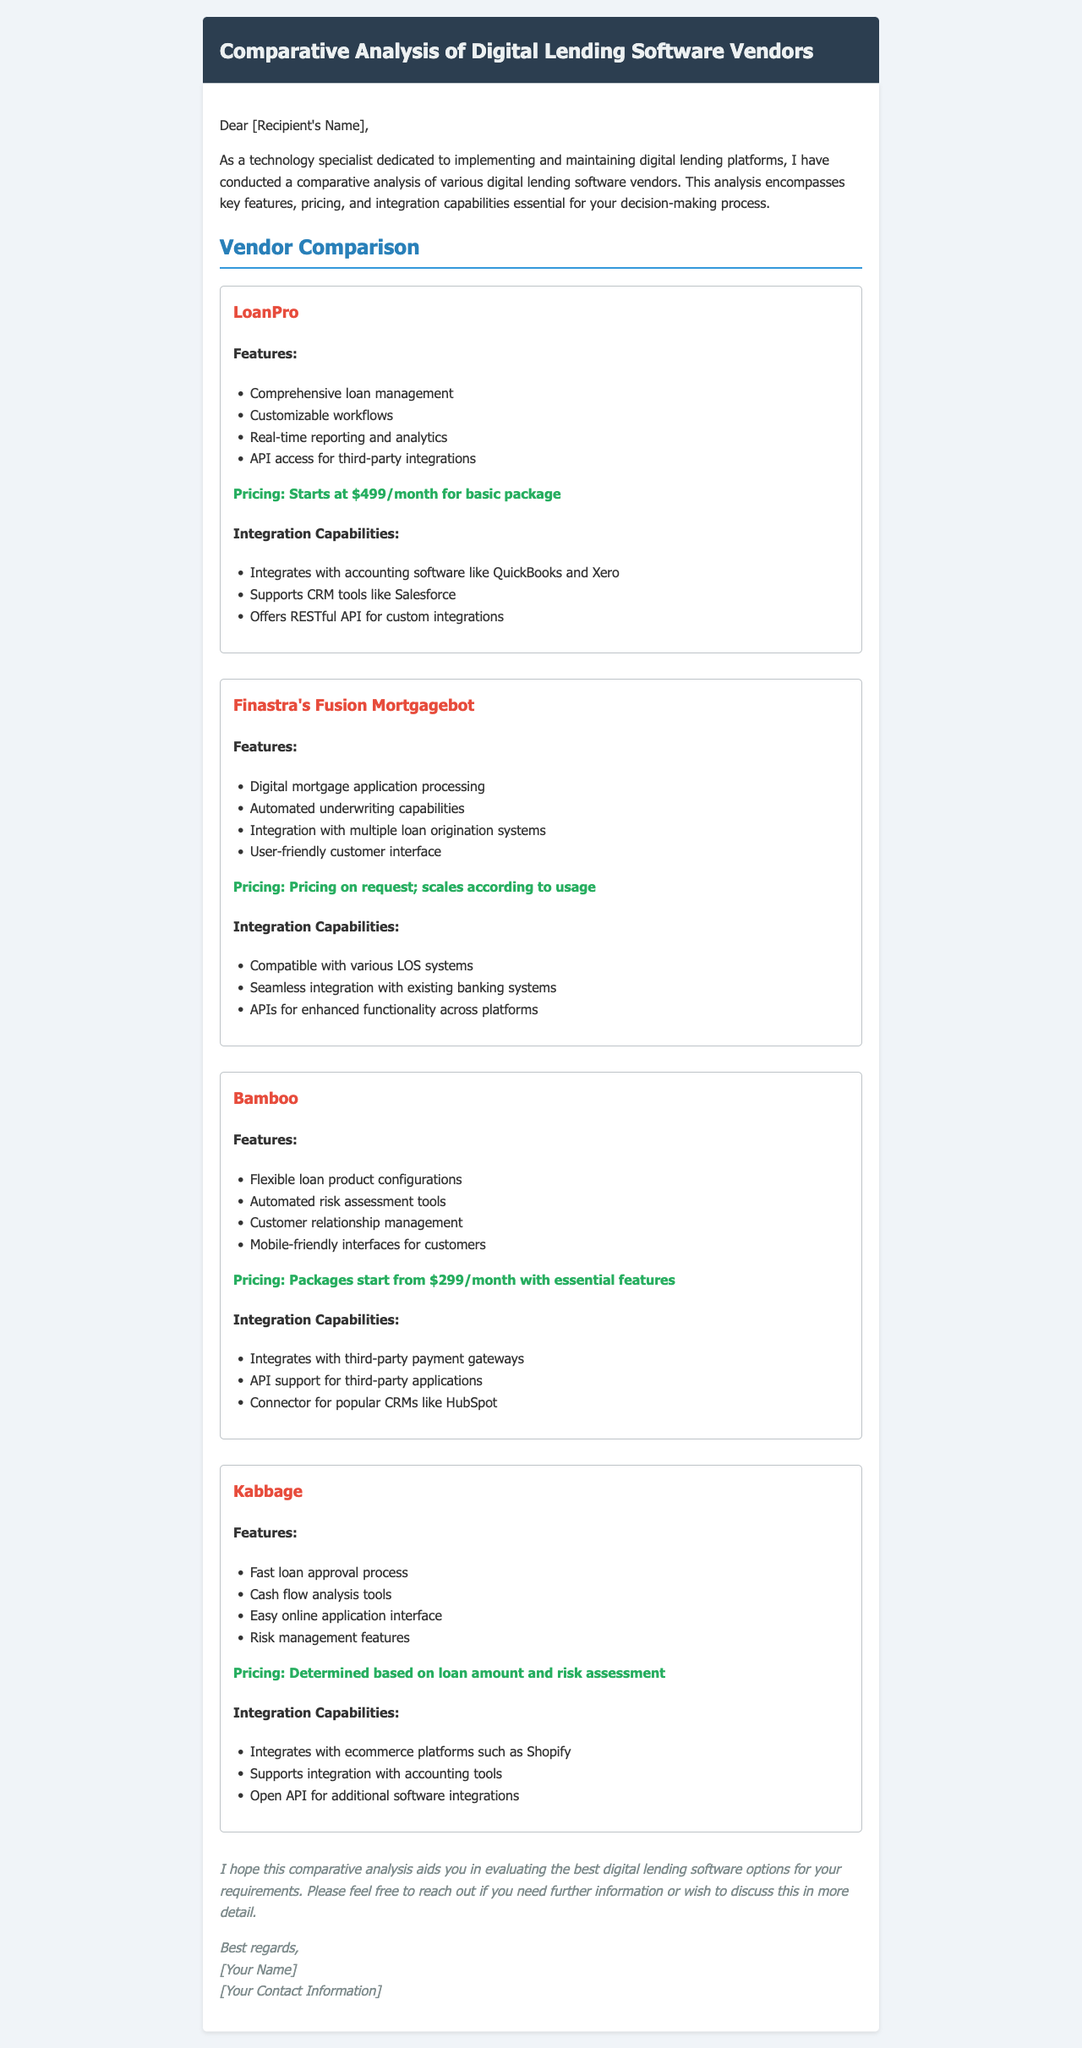What is the starting price for LoanPro's basic package? The starting price for LoanPro's basic package is specifically mentioned in the document.
Answer: $499/month Which vendor offers automated underwriting capabilities? Automated underwriting capabilities are highlighted as a feature of a specific vendor.
Answer: Finastra's Fusion Mortgagebot What feature is common among all vendors? The analysis highlights different features for each vendor, asking for a common feature requires evaluation across the vendors.
Answer: Integration capabilities What is Bamboo's starting package price? The document clearly states the starting package price for Bamboo's features.
Answer: $299/month Which vendor integrates with Shopify? The document indicates which vendor supports integration with the specified e-commerce platform.
Answer: Kabbage How many features does Finastra's Fusion Mortgagebot have listed? The number of features for each vendor is explicitly mentioned, demonstrating the diversity of offerings.
Answer: Four Is API access for third-party integrations a feature of LoanPro? The presence of API access as a feature is directly noted in the vendor's section.
Answer: Yes What type of analysis does Kabbage provide? Kabbage's section specifies the type of analysis related to their services.
Answer: Cash flow analysis tools Which vendor provides a mobile-friendly interface? The document specifies which vendor offers this feature by mentioning it in their description.
Answer: Bamboo 